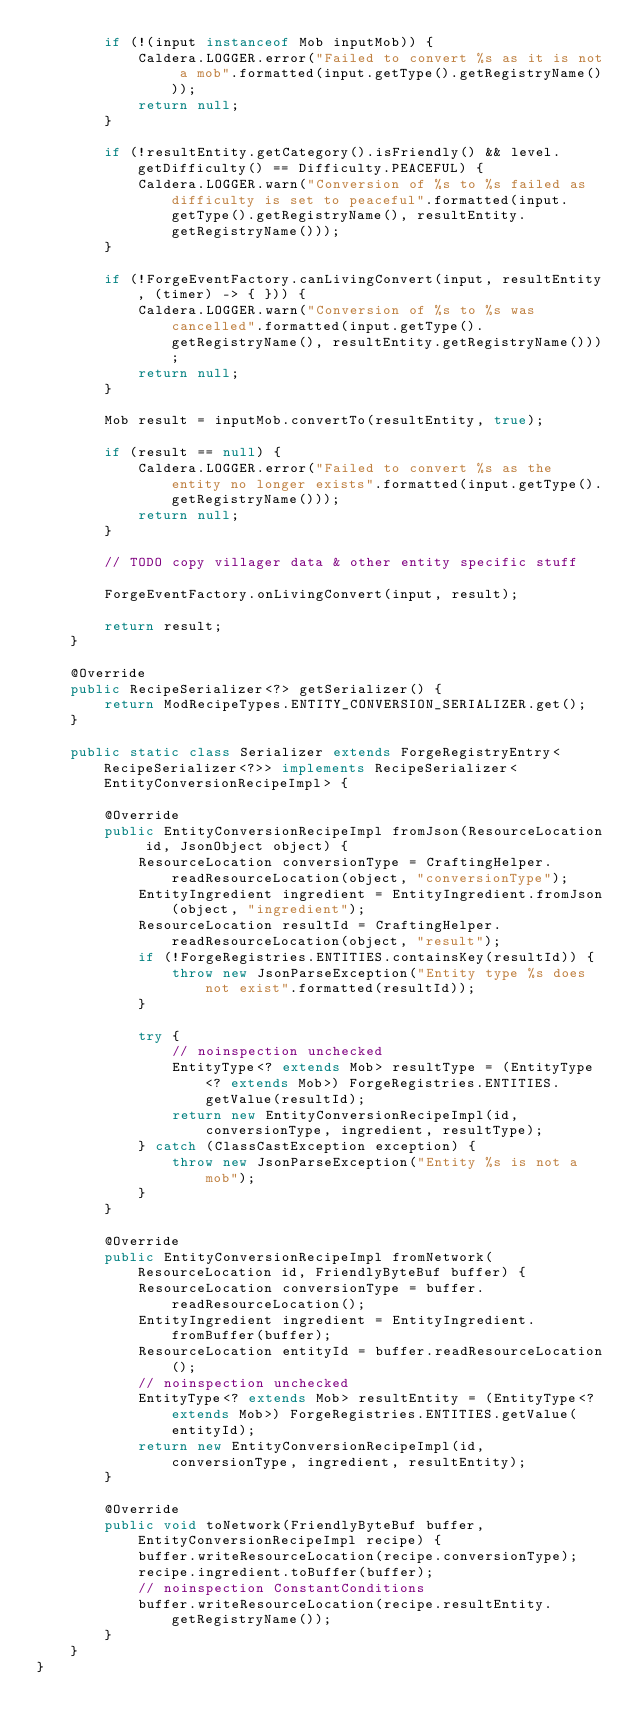Convert code to text. <code><loc_0><loc_0><loc_500><loc_500><_Java_>        if (!(input instanceof Mob inputMob)) {
            Caldera.LOGGER.error("Failed to convert %s as it is not a mob".formatted(input.getType().getRegistryName()));
            return null;
        }

        if (!resultEntity.getCategory().isFriendly() && level.getDifficulty() == Difficulty.PEACEFUL) {
            Caldera.LOGGER.warn("Conversion of %s to %s failed as difficulty is set to peaceful".formatted(input.getType().getRegistryName(), resultEntity.getRegistryName()));
        }

        if (!ForgeEventFactory.canLivingConvert(input, resultEntity, (timer) -> { })) {
            Caldera.LOGGER.warn("Conversion of %s to %s was cancelled".formatted(input.getType().getRegistryName(), resultEntity.getRegistryName()));
            return null;
        }

        Mob result = inputMob.convertTo(resultEntity, true);

        if (result == null) {
            Caldera.LOGGER.error("Failed to convert %s as the entity no longer exists".formatted(input.getType().getRegistryName()));
            return null;
        }

        // TODO copy villager data & other entity specific stuff

        ForgeEventFactory.onLivingConvert(input, result);

        return result;
    }

    @Override
    public RecipeSerializer<?> getSerializer() {
        return ModRecipeTypes.ENTITY_CONVERSION_SERIALIZER.get();
    }

    public static class Serializer extends ForgeRegistryEntry<RecipeSerializer<?>> implements RecipeSerializer<EntityConversionRecipeImpl> {

        @Override
        public EntityConversionRecipeImpl fromJson(ResourceLocation id, JsonObject object) {
            ResourceLocation conversionType = CraftingHelper.readResourceLocation(object, "conversionType");
            EntityIngredient ingredient = EntityIngredient.fromJson(object, "ingredient");
            ResourceLocation resultId = CraftingHelper.readResourceLocation(object, "result");
            if (!ForgeRegistries.ENTITIES.containsKey(resultId)) {
                throw new JsonParseException("Entity type %s does not exist".formatted(resultId));
            }

            try {
                // noinspection unchecked
                EntityType<? extends Mob> resultType = (EntityType<? extends Mob>) ForgeRegistries.ENTITIES.getValue(resultId);
                return new EntityConversionRecipeImpl(id, conversionType, ingredient, resultType);
            } catch (ClassCastException exception) {
                throw new JsonParseException("Entity %s is not a mob");
            }
        }

        @Override
        public EntityConversionRecipeImpl fromNetwork(ResourceLocation id, FriendlyByteBuf buffer) {
            ResourceLocation conversionType = buffer.readResourceLocation();
            EntityIngredient ingredient = EntityIngredient.fromBuffer(buffer);
            ResourceLocation entityId = buffer.readResourceLocation();
            // noinspection unchecked
            EntityType<? extends Mob> resultEntity = (EntityType<? extends Mob>) ForgeRegistries.ENTITIES.getValue(entityId);
            return new EntityConversionRecipeImpl(id, conversionType, ingredient, resultEntity);
        }

        @Override
        public void toNetwork(FriendlyByteBuf buffer, EntityConversionRecipeImpl recipe) {
            buffer.writeResourceLocation(recipe.conversionType);
            recipe.ingredient.toBuffer(buffer);
            // noinspection ConstantConditions
            buffer.writeResourceLocation(recipe.resultEntity.getRegistryName());
        }
    }
}
</code> 